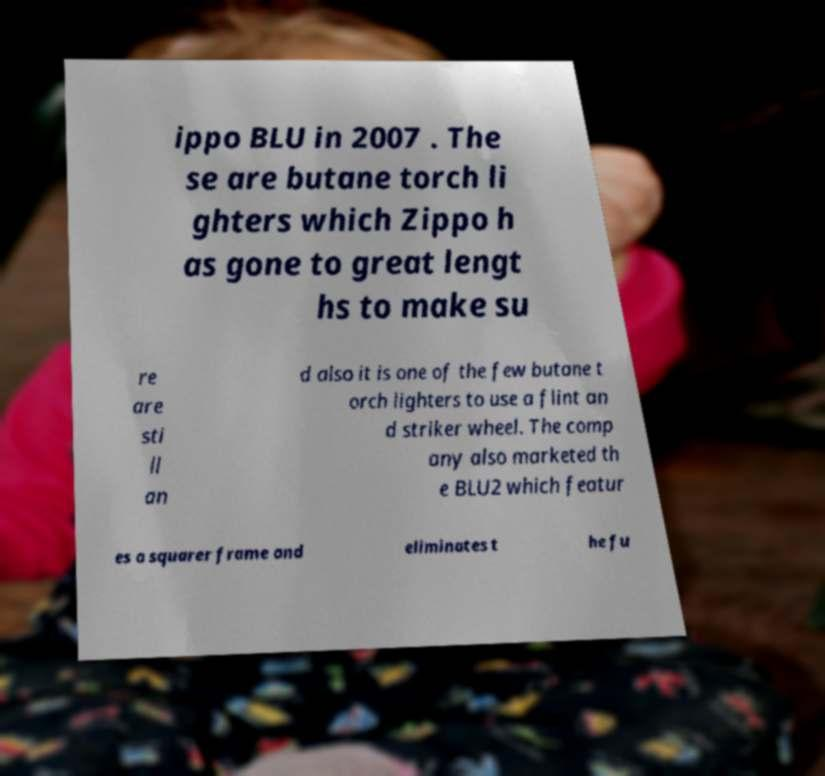Can you read and provide the text displayed in the image?This photo seems to have some interesting text. Can you extract and type it out for me? ippo BLU in 2007 . The se are butane torch li ghters which Zippo h as gone to great lengt hs to make su re are sti ll an d also it is one of the few butane t orch lighters to use a flint an d striker wheel. The comp any also marketed th e BLU2 which featur es a squarer frame and eliminates t he fu 